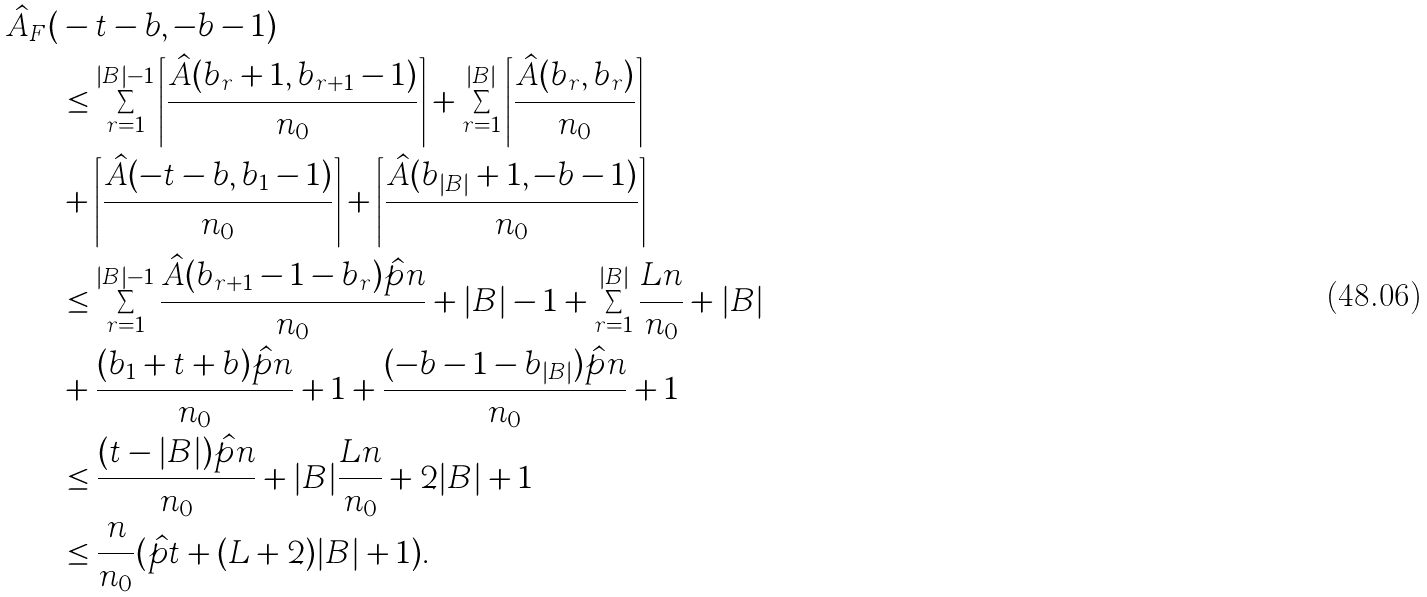<formula> <loc_0><loc_0><loc_500><loc_500>\hat { A } _ { F } ( & - t - b , - b - 1 ) \\ & \leq \sum _ { r = 1 } ^ { | B | - 1 } \left \lceil \frac { \hat { A } ( b _ { r } + 1 , b _ { r + 1 } - 1 ) } { n _ { 0 } } \right \rceil + \sum _ { r = 1 } ^ { | B | } \left \lceil \frac { \hat { A } ( b _ { r } , b _ { r } ) } { n _ { 0 } } \right \rceil \\ & + \left \lceil \frac { \hat { A } ( - t - b , b _ { 1 } - 1 ) } { n _ { 0 } } \right \rceil + \left \lceil \frac { \hat { A } ( b _ { | B | } + 1 , - b - 1 ) } { n _ { 0 } } \right \rceil \\ & \leq \sum _ { r = 1 } ^ { | B | - 1 } \frac { \hat { A } ( b _ { r + 1 } - 1 - b _ { r } ) \hat { p } n } { n _ { 0 } } + | B | - 1 + \sum _ { r = 1 } ^ { | B | } \frac { L n } { n _ { 0 } } + | B | \\ & + \frac { ( b _ { 1 } + t + b ) \hat { p } n } { n _ { 0 } } + 1 + \frac { ( - b - 1 - b _ { | B | } ) \hat { p } n } { n _ { 0 } } + 1 \\ & \leq \frac { ( t - | B | ) \hat { p } n } { n _ { 0 } } + | B | \frac { L n } { n _ { 0 } } + 2 | B | + 1 \\ & \leq \frac { n } { n _ { 0 } } ( \hat { p } t + ( L + 2 ) | B | + 1 ) .</formula> 